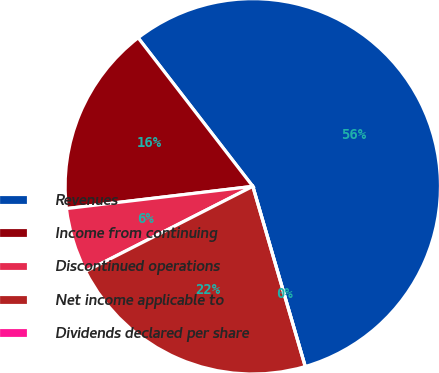Convert chart to OTSL. <chart><loc_0><loc_0><loc_500><loc_500><pie_chart><fcel>Revenues<fcel>Income from continuing<fcel>Discontinued operations<fcel>Net income applicable to<fcel>Dividends declared per share<nl><fcel>55.96%<fcel>16.43%<fcel>5.6%<fcel>22.02%<fcel>0.0%<nl></chart> 